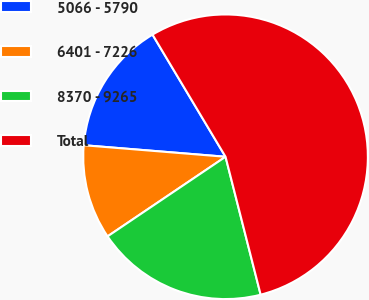<chart> <loc_0><loc_0><loc_500><loc_500><pie_chart><fcel>5066 - 5790<fcel>6401 - 7226<fcel>8370 - 9265<fcel>Total<nl><fcel>15.13%<fcel>10.74%<fcel>19.52%<fcel>54.61%<nl></chart> 